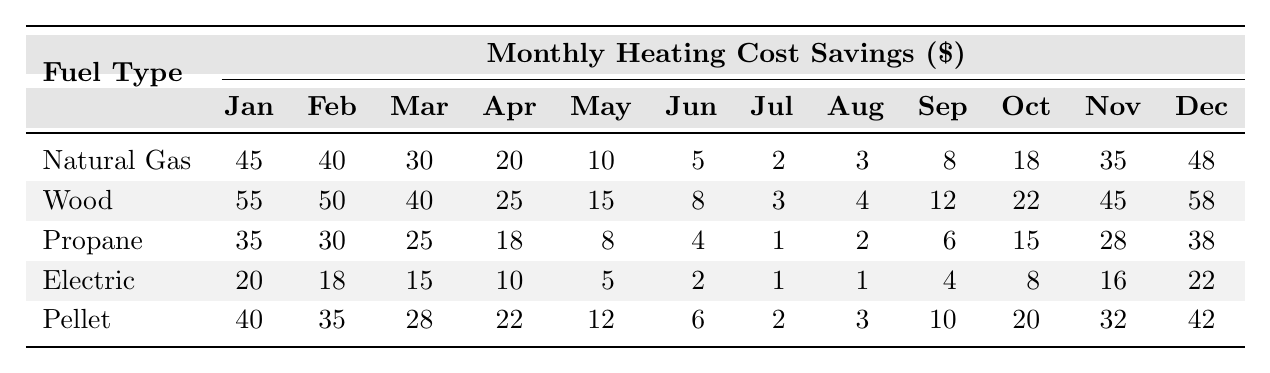What is the highest monthly heating cost savings for Wood? In the table, the values for Wood are listed under each month. The highest value is 58 in December.
Answer: 58 Which fuel type has the lowest heating cost savings in July? In July, the savings for each fuel type are listed as 2 (Natural Gas), 3 (Wood), 1 (Propane), 1 (Electric), and 2 (Pellet). The lowest value is 1, which applies to both Propane and Electric.
Answer: Propane and Electric What is the total heating cost savings for Natural Gas over the year? To calculate the total savings for Natural Gas, sum the values across all months: 45 + 40 + 30 + 20 + 10 + 5 + 2 + 3 + 8 + 18 + 35 + 48 = 218.
Answer: 218 Is the heating cost savings for Pellet higher than that of Electric in November? In November, Pellet shows 32 and Electric shows 16. Since 32 is greater than 16, Pellet has higher savings.
Answer: Yes Which fuel type averaged the highest heating cost savings over the entire year? Calculate the average for each fuel type by summing the savings for the year and dividing by 12. Natural Gas: 218/12 = 18.17, Wood: 329/12 = 27.42, Propane: 240/12 = 20, Electric: 12/12 = 10, Pellet: 246/12 = 20.5. The highest average is Wood at 27.42.
Answer: Wood How much more does Pellet save compared to Natural Gas in January? In January, Pellet saves 40 while Natural Gas saves 45. The difference is 45 - 40 = 5.
Answer: 5 Which month has the highest overall savings among all fuel types? Looking at the December values: Natural Gas (48), Wood (58), Propane (38), Electric (22), Pellet (42), the highest is Wood at 58.
Answer: December If you were to consider saving costs across the entire year, how much do the savings for all fuel types combined total? Total the savings for each fuel type: Natural Gas: 218, Wood: 329, Propane: 240, Electric: 122, Pellet: 246. Total = 218 + 329 + 240 + 122 + 246 = 1155.
Answer: 1155 Which fuel type has the most consistent savings throughout the months based on the table? Review the monthly savings for each fuel type. Electric shows a steady decrease but lower values overall. Natural Gas shows fluctuations, while Wood generally maintains higher amounts across months compared to others. Wood also maintains higher values consistently across months.
Answer: Wood In what month does Wood see a decrease in savings compared to the previous month for the first time? Checking the values month by month for Wood: January (55), February (50) - decrease happens here.
Answer: February 